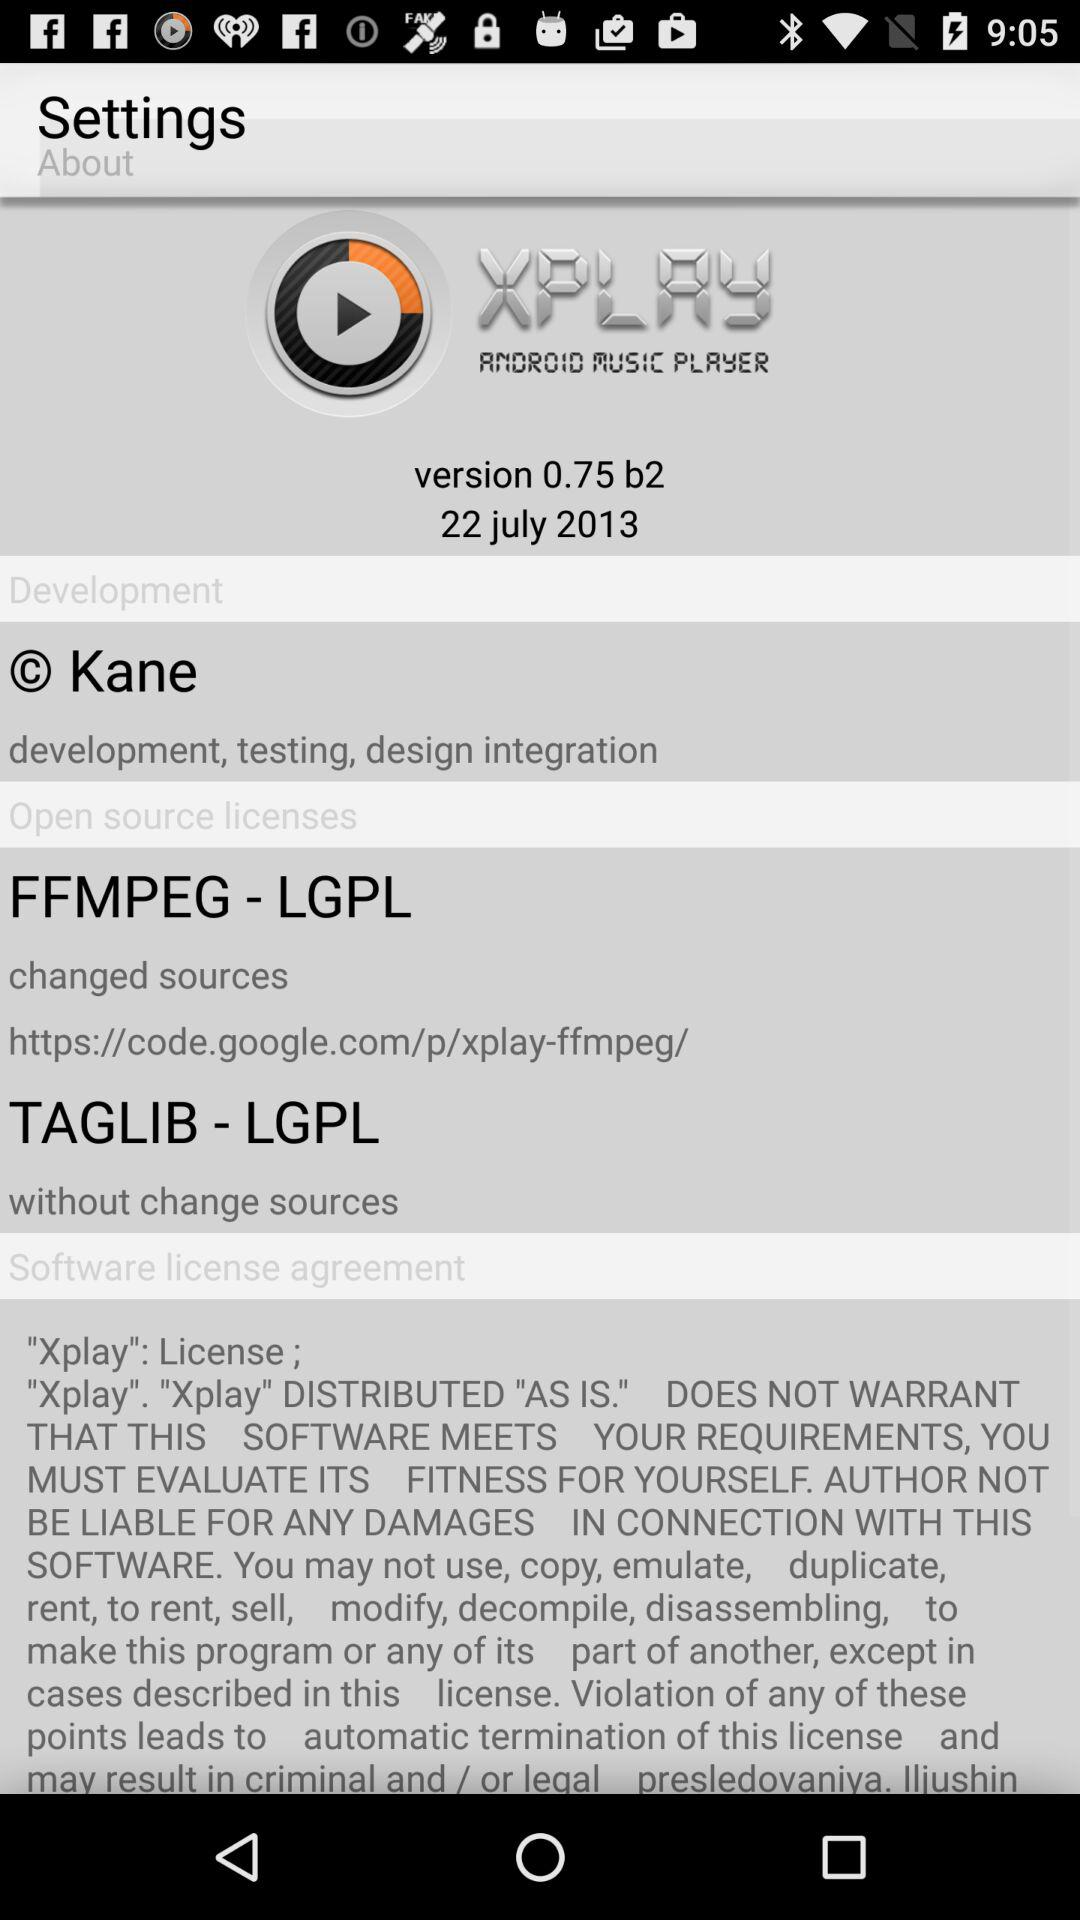What is the name of the version? The name of the version is 0.75 b2. 